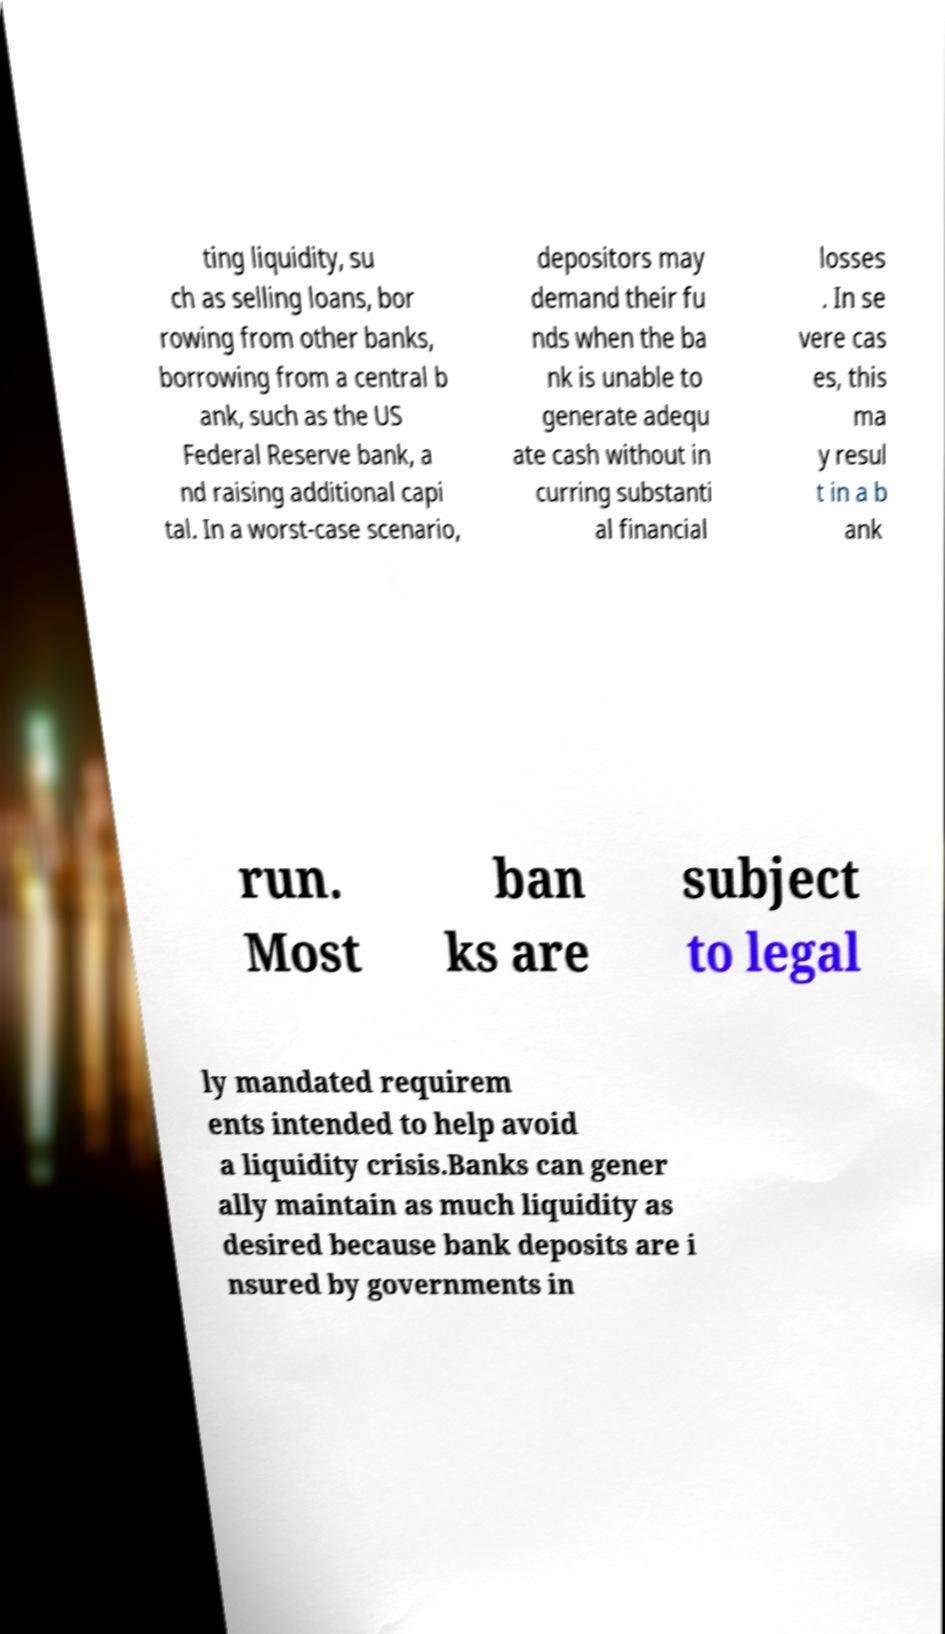Could you assist in decoding the text presented in this image and type it out clearly? ting liquidity, su ch as selling loans, bor rowing from other banks, borrowing from a central b ank, such as the US Federal Reserve bank, a nd raising additional capi tal. In a worst-case scenario, depositors may demand their fu nds when the ba nk is unable to generate adequ ate cash without in curring substanti al financial losses . In se vere cas es, this ma y resul t in a b ank run. Most ban ks are subject to legal ly mandated requirem ents intended to help avoid a liquidity crisis.Banks can gener ally maintain as much liquidity as desired because bank deposits are i nsured by governments in 